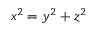<formula> <loc_0><loc_0><loc_500><loc_500>x ^ { 2 } = y ^ { 2 } + z ^ { 2 }</formula> 